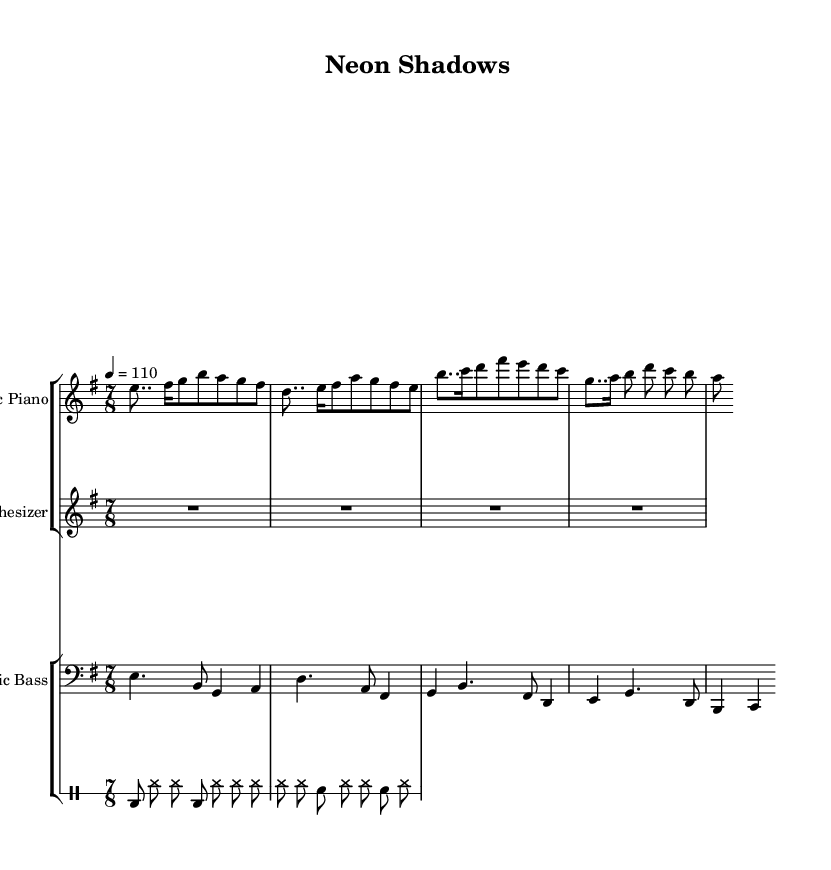What is the key signature of this music? The key signature is indicated by the key signature symbol (not shown here but generally at the beginning of the staff), which corresponds to E minor, having 1 sharp (F sharp).
Answer: E minor What is the time signature of the piece? The time signature appears as a fraction at the beginning of the music, indicating that there are 7 beats in a measure and the eighth note gets the beat. Thus, it is 7/8.
Answer: 7/8 What is the tempo marking provided? The tempo is specified as a number indicating beats per minute. In this case, "4 = 110" indicates that there are 110 beats per minute, corresponding to a quarter note.
Answer: 110 How many measures does the electric piano part consist of? By examining the electric piano staff, we can count the number of distinct measures represented, which amounts to 4 measures as indicated by the end of the notes.
Answer: 4 What type of instrument is represented by the second staff? The second staff is labeled "Synthesizer," which designates it as an electronic instrument that produces sound using synthesizing techniques.
Answer: Synthesizer Which instrument plays the bass line? The bass line is notated on a bass clef staff with the label "Electric Bass," indicating that this instrument is responsible for playing the lower harmonies and rhythms typical in jazz.
Answer: Electric Bass What rhythmic figure appears most frequently in the drum part? When analyzing the drum part, it becomes clear that the high hat (hh) appears most often and serves as a key rhythmic element in the accompaniment.
Answer: High hat 